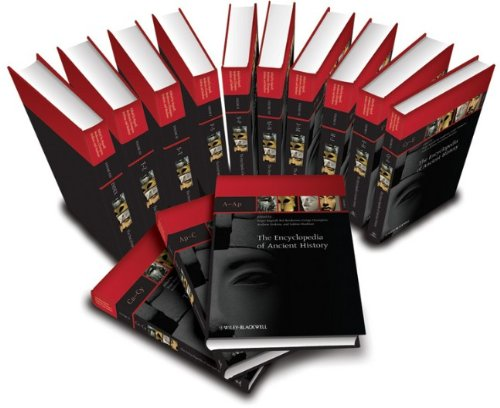What is the title of this book?
Answer the question using a single word or phrase. The Encyclopedia of Ancient History, 13 Volume Set What is the genre of this book? Reference Is this book related to Reference? Yes Is this book related to Science & Math? No 